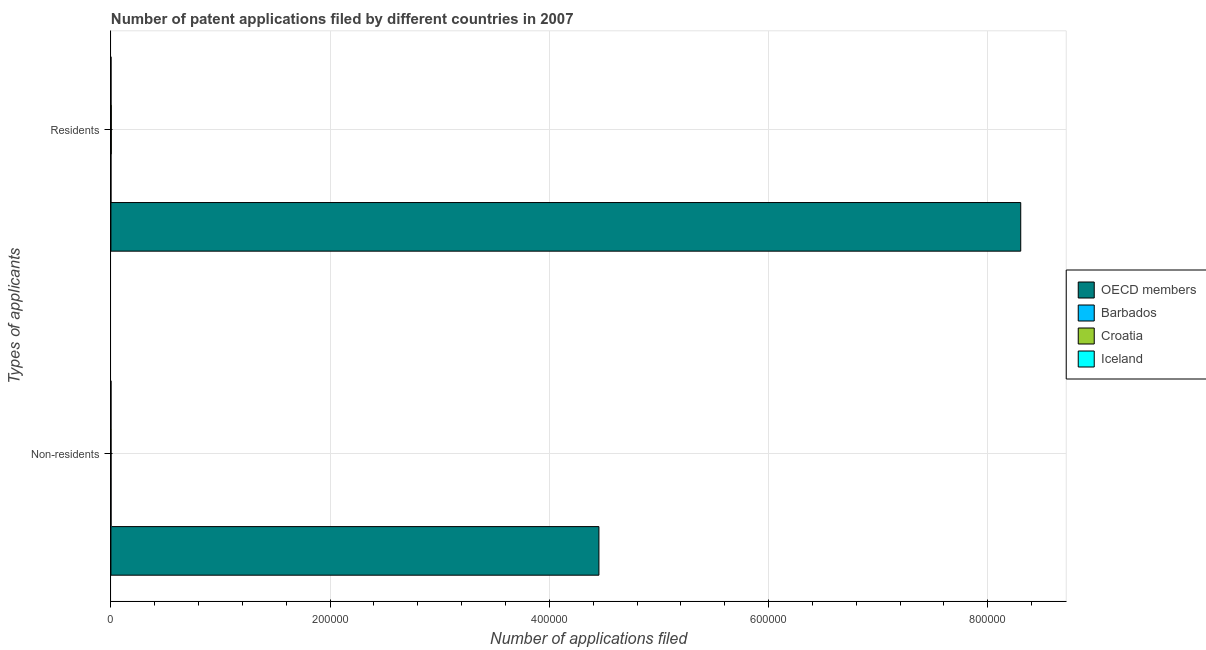How many different coloured bars are there?
Your answer should be compact. 4. Are the number of bars per tick equal to the number of legend labels?
Provide a short and direct response. Yes. Are the number of bars on each tick of the Y-axis equal?
Ensure brevity in your answer.  Yes. How many bars are there on the 2nd tick from the top?
Provide a short and direct response. 4. How many bars are there on the 1st tick from the bottom?
Make the answer very short. 4. What is the label of the 1st group of bars from the top?
Provide a succinct answer. Residents. What is the number of patent applications by residents in Barbados?
Offer a very short reply. 3. Across all countries, what is the maximum number of patent applications by residents?
Provide a succinct answer. 8.30e+05. Across all countries, what is the minimum number of patent applications by residents?
Offer a very short reply. 3. In which country was the number of patent applications by residents maximum?
Keep it short and to the point. OECD members. In which country was the number of patent applications by non residents minimum?
Give a very brief answer. Iceland. What is the total number of patent applications by residents in the graph?
Provide a short and direct response. 8.30e+05. What is the difference between the number of patent applications by non residents in Croatia and that in Iceland?
Make the answer very short. 40. What is the difference between the number of patent applications by non residents in Barbados and the number of patent applications by residents in Croatia?
Provide a short and direct response. -235. What is the average number of patent applications by non residents per country?
Give a very brief answer. 1.11e+05. What is the difference between the number of patent applications by non residents and number of patent applications by residents in Iceland?
Your response must be concise. -8. What is the ratio of the number of patent applications by non residents in Croatia to that in Barbados?
Provide a short and direct response. 0.85. Is the number of patent applications by residents in OECD members less than that in Iceland?
Keep it short and to the point. No. What does the 4th bar from the bottom in Residents represents?
Give a very brief answer. Iceland. How many bars are there?
Offer a terse response. 8. Are all the bars in the graph horizontal?
Provide a short and direct response. Yes. How many countries are there in the graph?
Keep it short and to the point. 4. What is the difference between two consecutive major ticks on the X-axis?
Make the answer very short. 2.00e+05. What is the title of the graph?
Provide a short and direct response. Number of patent applications filed by different countries in 2007. What is the label or title of the X-axis?
Provide a short and direct response. Number of applications filed. What is the label or title of the Y-axis?
Give a very brief answer. Types of applicants. What is the Number of applications filed in OECD members in Non-residents?
Provide a short and direct response. 4.45e+05. What is the Number of applications filed of Barbados in Non-residents?
Ensure brevity in your answer.  109. What is the Number of applications filed of Croatia in Non-residents?
Keep it short and to the point. 93. What is the Number of applications filed of OECD members in Residents?
Keep it short and to the point. 8.30e+05. What is the Number of applications filed in Croatia in Residents?
Your answer should be very brief. 344. Across all Types of applicants, what is the maximum Number of applications filed in OECD members?
Make the answer very short. 8.30e+05. Across all Types of applicants, what is the maximum Number of applications filed of Barbados?
Give a very brief answer. 109. Across all Types of applicants, what is the maximum Number of applications filed of Croatia?
Your answer should be compact. 344. Across all Types of applicants, what is the minimum Number of applications filed of OECD members?
Your answer should be compact. 4.45e+05. Across all Types of applicants, what is the minimum Number of applications filed of Croatia?
Your answer should be very brief. 93. What is the total Number of applications filed in OECD members in the graph?
Offer a terse response. 1.28e+06. What is the total Number of applications filed in Barbados in the graph?
Offer a terse response. 112. What is the total Number of applications filed in Croatia in the graph?
Provide a succinct answer. 437. What is the total Number of applications filed of Iceland in the graph?
Provide a succinct answer. 114. What is the difference between the Number of applications filed of OECD members in Non-residents and that in Residents?
Ensure brevity in your answer.  -3.85e+05. What is the difference between the Number of applications filed of Barbados in Non-residents and that in Residents?
Provide a succinct answer. 106. What is the difference between the Number of applications filed of Croatia in Non-residents and that in Residents?
Provide a succinct answer. -251. What is the difference between the Number of applications filed of OECD members in Non-residents and the Number of applications filed of Barbados in Residents?
Provide a succinct answer. 4.45e+05. What is the difference between the Number of applications filed of OECD members in Non-residents and the Number of applications filed of Croatia in Residents?
Ensure brevity in your answer.  4.45e+05. What is the difference between the Number of applications filed in OECD members in Non-residents and the Number of applications filed in Iceland in Residents?
Provide a short and direct response. 4.45e+05. What is the difference between the Number of applications filed of Barbados in Non-residents and the Number of applications filed of Croatia in Residents?
Your answer should be compact. -235. What is the difference between the Number of applications filed of Barbados in Non-residents and the Number of applications filed of Iceland in Residents?
Make the answer very short. 48. What is the average Number of applications filed of OECD members per Types of applicants?
Provide a short and direct response. 6.38e+05. What is the average Number of applications filed in Croatia per Types of applicants?
Keep it short and to the point. 218.5. What is the difference between the Number of applications filed in OECD members and Number of applications filed in Barbados in Non-residents?
Offer a very short reply. 4.45e+05. What is the difference between the Number of applications filed in OECD members and Number of applications filed in Croatia in Non-residents?
Your response must be concise. 4.45e+05. What is the difference between the Number of applications filed in OECD members and Number of applications filed in Iceland in Non-residents?
Give a very brief answer. 4.45e+05. What is the difference between the Number of applications filed of Barbados and Number of applications filed of Croatia in Non-residents?
Your answer should be compact. 16. What is the difference between the Number of applications filed in Barbados and Number of applications filed in Iceland in Non-residents?
Make the answer very short. 56. What is the difference between the Number of applications filed of OECD members and Number of applications filed of Barbados in Residents?
Offer a terse response. 8.30e+05. What is the difference between the Number of applications filed in OECD members and Number of applications filed in Croatia in Residents?
Offer a terse response. 8.30e+05. What is the difference between the Number of applications filed of OECD members and Number of applications filed of Iceland in Residents?
Your answer should be compact. 8.30e+05. What is the difference between the Number of applications filed of Barbados and Number of applications filed of Croatia in Residents?
Offer a terse response. -341. What is the difference between the Number of applications filed in Barbados and Number of applications filed in Iceland in Residents?
Offer a very short reply. -58. What is the difference between the Number of applications filed of Croatia and Number of applications filed of Iceland in Residents?
Your answer should be very brief. 283. What is the ratio of the Number of applications filed of OECD members in Non-residents to that in Residents?
Your answer should be compact. 0.54. What is the ratio of the Number of applications filed in Barbados in Non-residents to that in Residents?
Your answer should be compact. 36.33. What is the ratio of the Number of applications filed in Croatia in Non-residents to that in Residents?
Provide a succinct answer. 0.27. What is the ratio of the Number of applications filed of Iceland in Non-residents to that in Residents?
Your response must be concise. 0.87. What is the difference between the highest and the second highest Number of applications filed in OECD members?
Offer a terse response. 3.85e+05. What is the difference between the highest and the second highest Number of applications filed in Barbados?
Keep it short and to the point. 106. What is the difference between the highest and the second highest Number of applications filed of Croatia?
Offer a terse response. 251. What is the difference between the highest and the second highest Number of applications filed of Iceland?
Your response must be concise. 8. What is the difference between the highest and the lowest Number of applications filed of OECD members?
Make the answer very short. 3.85e+05. What is the difference between the highest and the lowest Number of applications filed of Barbados?
Give a very brief answer. 106. What is the difference between the highest and the lowest Number of applications filed of Croatia?
Your response must be concise. 251. 